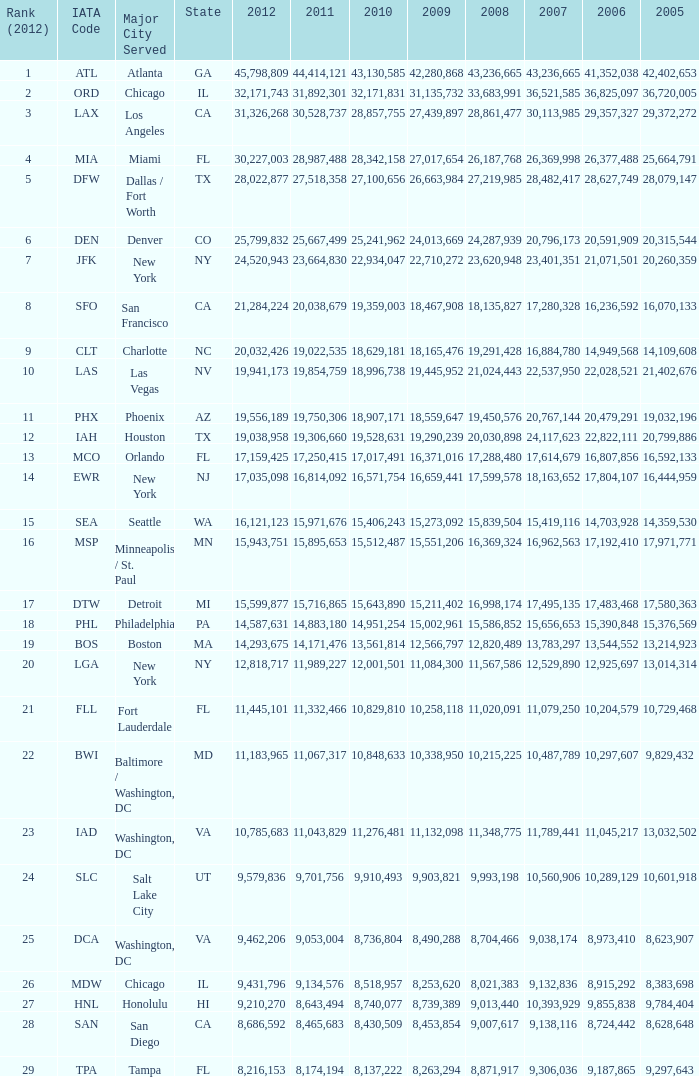For the iata code of lax with 2009 lesser than 31,135,732 and 2011 lesser than 8,174,194, what is the combined figure for 2012? 0.0. 